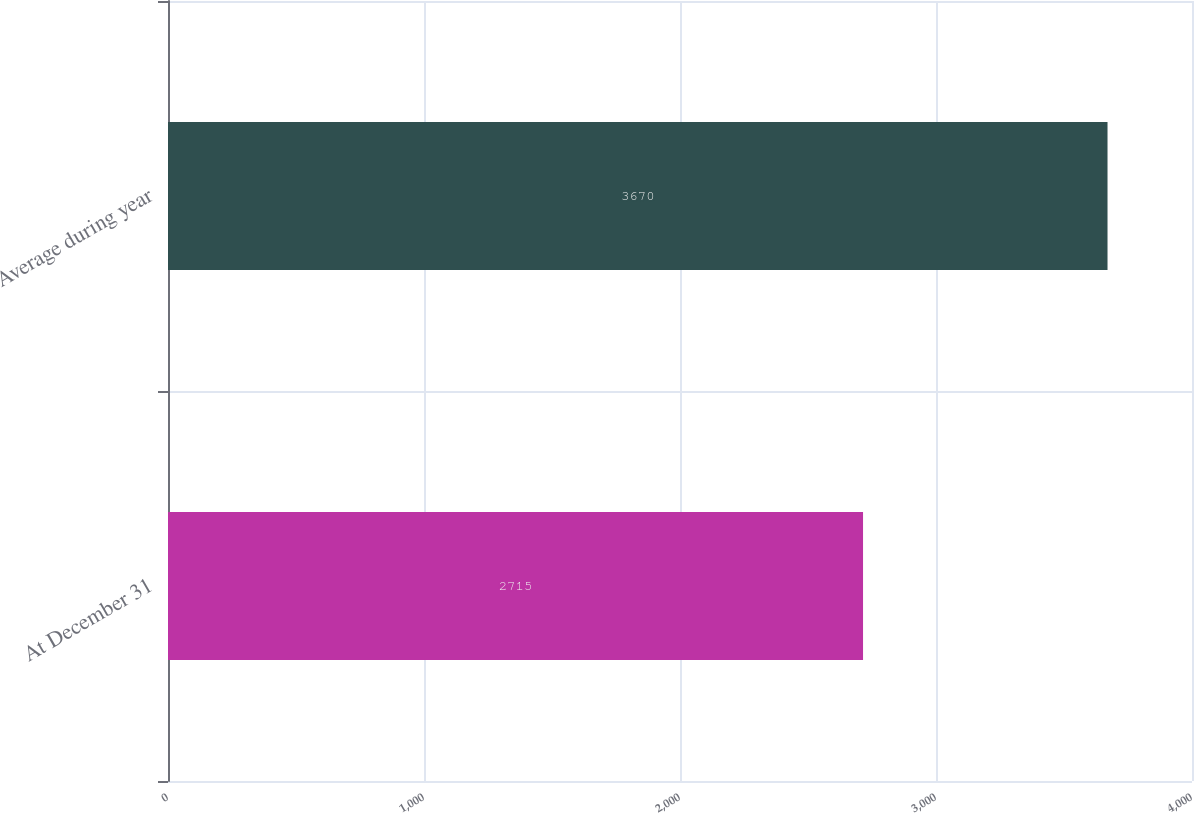<chart> <loc_0><loc_0><loc_500><loc_500><bar_chart><fcel>At December 31<fcel>Average during year<nl><fcel>2715<fcel>3670<nl></chart> 